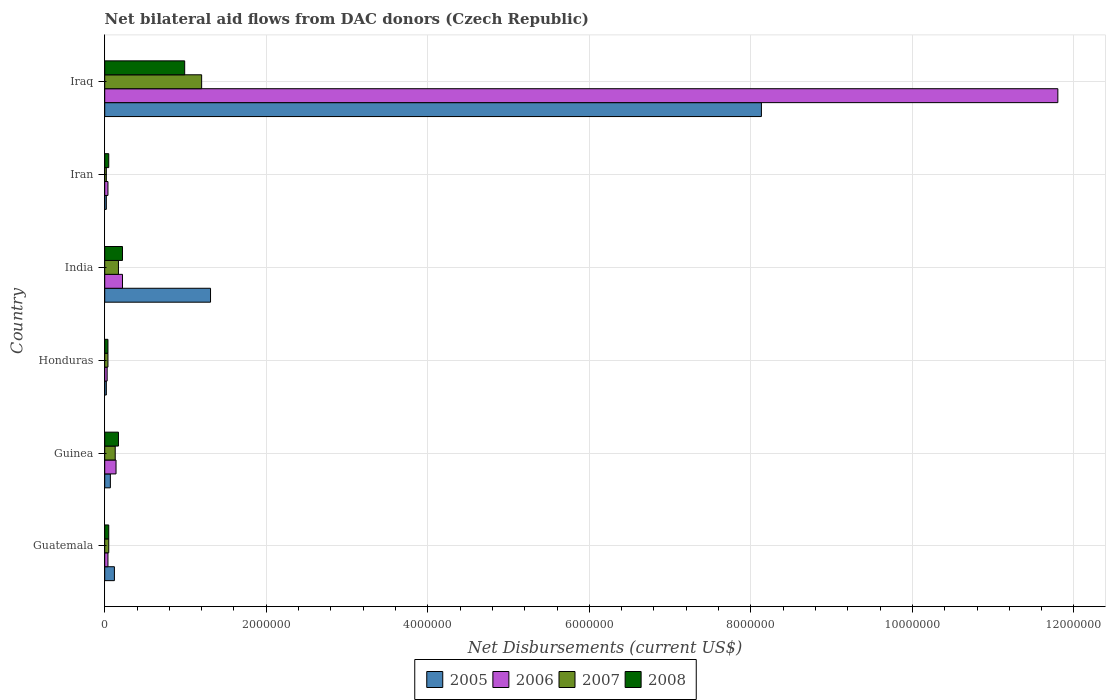How many groups of bars are there?
Provide a succinct answer. 6. Are the number of bars per tick equal to the number of legend labels?
Your answer should be compact. Yes. Are the number of bars on each tick of the Y-axis equal?
Your answer should be compact. Yes. How many bars are there on the 2nd tick from the top?
Provide a succinct answer. 4. What is the label of the 6th group of bars from the top?
Provide a succinct answer. Guatemala. In how many cases, is the number of bars for a given country not equal to the number of legend labels?
Offer a very short reply. 0. Across all countries, what is the maximum net bilateral aid flows in 2007?
Provide a succinct answer. 1.20e+06. Across all countries, what is the minimum net bilateral aid flows in 2007?
Ensure brevity in your answer.  2.00e+04. In which country was the net bilateral aid flows in 2008 maximum?
Make the answer very short. Iraq. In which country was the net bilateral aid flows in 2005 minimum?
Your answer should be very brief. Honduras. What is the total net bilateral aid flows in 2008 in the graph?
Provide a short and direct response. 1.52e+06. What is the difference between the net bilateral aid flows in 2005 in Guinea and that in Iraq?
Offer a terse response. -8.06e+06. What is the difference between the net bilateral aid flows in 2007 in Guinea and the net bilateral aid flows in 2006 in Iran?
Offer a terse response. 9.00e+04. What is the average net bilateral aid flows in 2007 per country?
Make the answer very short. 2.68e+05. What is the ratio of the net bilateral aid flows in 2008 in India to that in Iraq?
Your response must be concise. 0.22. Is the difference between the net bilateral aid flows in 2005 in Guinea and Iraq greater than the difference between the net bilateral aid flows in 2006 in Guinea and Iraq?
Your response must be concise. Yes. What is the difference between the highest and the second highest net bilateral aid flows in 2007?
Offer a very short reply. 1.03e+06. What is the difference between the highest and the lowest net bilateral aid flows in 2006?
Offer a very short reply. 1.18e+07. In how many countries, is the net bilateral aid flows in 2006 greater than the average net bilateral aid flows in 2006 taken over all countries?
Keep it short and to the point. 1. Is the sum of the net bilateral aid flows in 2005 in Guatemala and Guinea greater than the maximum net bilateral aid flows in 2006 across all countries?
Give a very brief answer. No. Is it the case that in every country, the sum of the net bilateral aid flows in 2007 and net bilateral aid flows in 2008 is greater than the sum of net bilateral aid flows in 2005 and net bilateral aid flows in 2006?
Offer a terse response. No. What does the 1st bar from the top in Guinea represents?
Offer a very short reply. 2008. What does the 4th bar from the bottom in Iran represents?
Your answer should be very brief. 2008. How many bars are there?
Your response must be concise. 24. How many countries are there in the graph?
Give a very brief answer. 6. What is the difference between two consecutive major ticks on the X-axis?
Offer a terse response. 2.00e+06. Does the graph contain any zero values?
Ensure brevity in your answer.  No. Where does the legend appear in the graph?
Your response must be concise. Bottom center. What is the title of the graph?
Ensure brevity in your answer.  Net bilateral aid flows from DAC donors (Czech Republic). What is the label or title of the X-axis?
Provide a short and direct response. Net Disbursements (current US$). What is the Net Disbursements (current US$) of 2005 in Guatemala?
Offer a terse response. 1.20e+05. What is the Net Disbursements (current US$) of 2005 in Guinea?
Provide a succinct answer. 7.00e+04. What is the Net Disbursements (current US$) of 2006 in Guinea?
Provide a short and direct response. 1.40e+05. What is the Net Disbursements (current US$) of 2008 in Guinea?
Keep it short and to the point. 1.70e+05. What is the Net Disbursements (current US$) of 2006 in Honduras?
Keep it short and to the point. 3.00e+04. What is the Net Disbursements (current US$) of 2007 in Honduras?
Provide a succinct answer. 4.00e+04. What is the Net Disbursements (current US$) in 2005 in India?
Keep it short and to the point. 1.31e+06. What is the Net Disbursements (current US$) of 2007 in India?
Ensure brevity in your answer.  1.70e+05. What is the Net Disbursements (current US$) in 2008 in India?
Make the answer very short. 2.20e+05. What is the Net Disbursements (current US$) of 2005 in Iran?
Provide a succinct answer. 2.00e+04. What is the Net Disbursements (current US$) in 2006 in Iran?
Keep it short and to the point. 4.00e+04. What is the Net Disbursements (current US$) of 2007 in Iran?
Give a very brief answer. 2.00e+04. What is the Net Disbursements (current US$) of 2008 in Iran?
Give a very brief answer. 5.00e+04. What is the Net Disbursements (current US$) in 2005 in Iraq?
Keep it short and to the point. 8.13e+06. What is the Net Disbursements (current US$) in 2006 in Iraq?
Your answer should be compact. 1.18e+07. What is the Net Disbursements (current US$) of 2007 in Iraq?
Ensure brevity in your answer.  1.20e+06. What is the Net Disbursements (current US$) of 2008 in Iraq?
Provide a succinct answer. 9.90e+05. Across all countries, what is the maximum Net Disbursements (current US$) of 2005?
Offer a terse response. 8.13e+06. Across all countries, what is the maximum Net Disbursements (current US$) of 2006?
Ensure brevity in your answer.  1.18e+07. Across all countries, what is the maximum Net Disbursements (current US$) of 2007?
Provide a short and direct response. 1.20e+06. Across all countries, what is the maximum Net Disbursements (current US$) in 2008?
Offer a very short reply. 9.90e+05. Across all countries, what is the minimum Net Disbursements (current US$) in 2006?
Give a very brief answer. 3.00e+04. Across all countries, what is the minimum Net Disbursements (current US$) in 2007?
Give a very brief answer. 2.00e+04. What is the total Net Disbursements (current US$) in 2005 in the graph?
Provide a short and direct response. 9.67e+06. What is the total Net Disbursements (current US$) of 2006 in the graph?
Your response must be concise. 1.23e+07. What is the total Net Disbursements (current US$) in 2007 in the graph?
Ensure brevity in your answer.  1.61e+06. What is the total Net Disbursements (current US$) in 2008 in the graph?
Your answer should be compact. 1.52e+06. What is the difference between the Net Disbursements (current US$) of 2005 in Guatemala and that in Guinea?
Make the answer very short. 5.00e+04. What is the difference between the Net Disbursements (current US$) in 2006 in Guatemala and that in Guinea?
Make the answer very short. -1.00e+05. What is the difference between the Net Disbursements (current US$) in 2007 in Guatemala and that in Guinea?
Offer a terse response. -8.00e+04. What is the difference between the Net Disbursements (current US$) of 2005 in Guatemala and that in Honduras?
Make the answer very short. 1.00e+05. What is the difference between the Net Disbursements (current US$) in 2006 in Guatemala and that in Honduras?
Ensure brevity in your answer.  10000. What is the difference between the Net Disbursements (current US$) in 2007 in Guatemala and that in Honduras?
Offer a very short reply. 10000. What is the difference between the Net Disbursements (current US$) in 2005 in Guatemala and that in India?
Offer a very short reply. -1.19e+06. What is the difference between the Net Disbursements (current US$) in 2006 in Guatemala and that in India?
Offer a very short reply. -1.80e+05. What is the difference between the Net Disbursements (current US$) of 2005 in Guatemala and that in Iran?
Your answer should be compact. 1.00e+05. What is the difference between the Net Disbursements (current US$) in 2006 in Guatemala and that in Iran?
Your response must be concise. 0. What is the difference between the Net Disbursements (current US$) in 2005 in Guatemala and that in Iraq?
Ensure brevity in your answer.  -8.01e+06. What is the difference between the Net Disbursements (current US$) of 2006 in Guatemala and that in Iraq?
Provide a succinct answer. -1.18e+07. What is the difference between the Net Disbursements (current US$) of 2007 in Guatemala and that in Iraq?
Provide a short and direct response. -1.15e+06. What is the difference between the Net Disbursements (current US$) in 2008 in Guatemala and that in Iraq?
Provide a succinct answer. -9.40e+05. What is the difference between the Net Disbursements (current US$) in 2005 in Guinea and that in Honduras?
Keep it short and to the point. 5.00e+04. What is the difference between the Net Disbursements (current US$) of 2005 in Guinea and that in India?
Offer a terse response. -1.24e+06. What is the difference between the Net Disbursements (current US$) of 2007 in Guinea and that in India?
Keep it short and to the point. -4.00e+04. What is the difference between the Net Disbursements (current US$) of 2005 in Guinea and that in Iran?
Make the answer very short. 5.00e+04. What is the difference between the Net Disbursements (current US$) of 2006 in Guinea and that in Iran?
Your response must be concise. 1.00e+05. What is the difference between the Net Disbursements (current US$) in 2008 in Guinea and that in Iran?
Keep it short and to the point. 1.20e+05. What is the difference between the Net Disbursements (current US$) in 2005 in Guinea and that in Iraq?
Your response must be concise. -8.06e+06. What is the difference between the Net Disbursements (current US$) of 2006 in Guinea and that in Iraq?
Give a very brief answer. -1.17e+07. What is the difference between the Net Disbursements (current US$) of 2007 in Guinea and that in Iraq?
Give a very brief answer. -1.07e+06. What is the difference between the Net Disbursements (current US$) in 2008 in Guinea and that in Iraq?
Keep it short and to the point. -8.20e+05. What is the difference between the Net Disbursements (current US$) in 2005 in Honduras and that in India?
Provide a short and direct response. -1.29e+06. What is the difference between the Net Disbursements (current US$) in 2007 in Honduras and that in India?
Your answer should be compact. -1.30e+05. What is the difference between the Net Disbursements (current US$) in 2008 in Honduras and that in India?
Provide a short and direct response. -1.80e+05. What is the difference between the Net Disbursements (current US$) in 2006 in Honduras and that in Iran?
Give a very brief answer. -10000. What is the difference between the Net Disbursements (current US$) in 2008 in Honduras and that in Iran?
Your answer should be compact. -10000. What is the difference between the Net Disbursements (current US$) of 2005 in Honduras and that in Iraq?
Provide a succinct answer. -8.11e+06. What is the difference between the Net Disbursements (current US$) of 2006 in Honduras and that in Iraq?
Offer a very short reply. -1.18e+07. What is the difference between the Net Disbursements (current US$) in 2007 in Honduras and that in Iraq?
Keep it short and to the point. -1.16e+06. What is the difference between the Net Disbursements (current US$) in 2008 in Honduras and that in Iraq?
Offer a terse response. -9.50e+05. What is the difference between the Net Disbursements (current US$) of 2005 in India and that in Iran?
Your answer should be very brief. 1.29e+06. What is the difference between the Net Disbursements (current US$) in 2006 in India and that in Iran?
Your answer should be compact. 1.80e+05. What is the difference between the Net Disbursements (current US$) of 2005 in India and that in Iraq?
Your answer should be compact. -6.82e+06. What is the difference between the Net Disbursements (current US$) of 2006 in India and that in Iraq?
Offer a terse response. -1.16e+07. What is the difference between the Net Disbursements (current US$) in 2007 in India and that in Iraq?
Keep it short and to the point. -1.03e+06. What is the difference between the Net Disbursements (current US$) of 2008 in India and that in Iraq?
Ensure brevity in your answer.  -7.70e+05. What is the difference between the Net Disbursements (current US$) in 2005 in Iran and that in Iraq?
Offer a terse response. -8.11e+06. What is the difference between the Net Disbursements (current US$) in 2006 in Iran and that in Iraq?
Offer a very short reply. -1.18e+07. What is the difference between the Net Disbursements (current US$) of 2007 in Iran and that in Iraq?
Your response must be concise. -1.18e+06. What is the difference between the Net Disbursements (current US$) of 2008 in Iran and that in Iraq?
Offer a very short reply. -9.40e+05. What is the difference between the Net Disbursements (current US$) of 2005 in Guatemala and the Net Disbursements (current US$) of 2006 in Guinea?
Make the answer very short. -2.00e+04. What is the difference between the Net Disbursements (current US$) in 2005 in Guatemala and the Net Disbursements (current US$) in 2007 in Guinea?
Make the answer very short. -10000. What is the difference between the Net Disbursements (current US$) of 2005 in Guatemala and the Net Disbursements (current US$) of 2008 in Guinea?
Ensure brevity in your answer.  -5.00e+04. What is the difference between the Net Disbursements (current US$) of 2006 in Guatemala and the Net Disbursements (current US$) of 2007 in Guinea?
Offer a terse response. -9.00e+04. What is the difference between the Net Disbursements (current US$) in 2007 in Guatemala and the Net Disbursements (current US$) in 2008 in Guinea?
Give a very brief answer. -1.20e+05. What is the difference between the Net Disbursements (current US$) of 2005 in Guatemala and the Net Disbursements (current US$) of 2006 in Honduras?
Provide a succinct answer. 9.00e+04. What is the difference between the Net Disbursements (current US$) in 2005 in Guatemala and the Net Disbursements (current US$) in 2008 in Honduras?
Provide a succinct answer. 8.00e+04. What is the difference between the Net Disbursements (current US$) of 2007 in Guatemala and the Net Disbursements (current US$) of 2008 in Honduras?
Your response must be concise. 10000. What is the difference between the Net Disbursements (current US$) of 2005 in Guatemala and the Net Disbursements (current US$) of 2007 in India?
Offer a very short reply. -5.00e+04. What is the difference between the Net Disbursements (current US$) of 2006 in Guatemala and the Net Disbursements (current US$) of 2008 in India?
Provide a succinct answer. -1.80e+05. What is the difference between the Net Disbursements (current US$) in 2007 in Guatemala and the Net Disbursements (current US$) in 2008 in India?
Offer a terse response. -1.70e+05. What is the difference between the Net Disbursements (current US$) in 2005 in Guatemala and the Net Disbursements (current US$) in 2006 in Iran?
Offer a very short reply. 8.00e+04. What is the difference between the Net Disbursements (current US$) of 2006 in Guatemala and the Net Disbursements (current US$) of 2007 in Iran?
Keep it short and to the point. 2.00e+04. What is the difference between the Net Disbursements (current US$) in 2006 in Guatemala and the Net Disbursements (current US$) in 2008 in Iran?
Provide a succinct answer. -10000. What is the difference between the Net Disbursements (current US$) in 2005 in Guatemala and the Net Disbursements (current US$) in 2006 in Iraq?
Your answer should be compact. -1.17e+07. What is the difference between the Net Disbursements (current US$) in 2005 in Guatemala and the Net Disbursements (current US$) in 2007 in Iraq?
Give a very brief answer. -1.08e+06. What is the difference between the Net Disbursements (current US$) in 2005 in Guatemala and the Net Disbursements (current US$) in 2008 in Iraq?
Offer a terse response. -8.70e+05. What is the difference between the Net Disbursements (current US$) in 2006 in Guatemala and the Net Disbursements (current US$) in 2007 in Iraq?
Keep it short and to the point. -1.16e+06. What is the difference between the Net Disbursements (current US$) in 2006 in Guatemala and the Net Disbursements (current US$) in 2008 in Iraq?
Offer a very short reply. -9.50e+05. What is the difference between the Net Disbursements (current US$) of 2007 in Guatemala and the Net Disbursements (current US$) of 2008 in Iraq?
Offer a very short reply. -9.40e+05. What is the difference between the Net Disbursements (current US$) in 2005 in Guinea and the Net Disbursements (current US$) in 2006 in Honduras?
Make the answer very short. 4.00e+04. What is the difference between the Net Disbursements (current US$) of 2005 in Guinea and the Net Disbursements (current US$) of 2007 in Honduras?
Keep it short and to the point. 3.00e+04. What is the difference between the Net Disbursements (current US$) of 2005 in Guinea and the Net Disbursements (current US$) of 2008 in Honduras?
Keep it short and to the point. 3.00e+04. What is the difference between the Net Disbursements (current US$) in 2006 in Guinea and the Net Disbursements (current US$) in 2007 in Honduras?
Offer a terse response. 1.00e+05. What is the difference between the Net Disbursements (current US$) of 2006 in Guinea and the Net Disbursements (current US$) of 2008 in Honduras?
Give a very brief answer. 1.00e+05. What is the difference between the Net Disbursements (current US$) in 2005 in Guinea and the Net Disbursements (current US$) in 2006 in India?
Offer a very short reply. -1.50e+05. What is the difference between the Net Disbursements (current US$) in 2007 in Guinea and the Net Disbursements (current US$) in 2008 in India?
Give a very brief answer. -9.00e+04. What is the difference between the Net Disbursements (current US$) in 2005 in Guinea and the Net Disbursements (current US$) in 2007 in Iran?
Offer a very short reply. 5.00e+04. What is the difference between the Net Disbursements (current US$) in 2005 in Guinea and the Net Disbursements (current US$) in 2008 in Iran?
Make the answer very short. 2.00e+04. What is the difference between the Net Disbursements (current US$) in 2007 in Guinea and the Net Disbursements (current US$) in 2008 in Iran?
Your answer should be compact. 8.00e+04. What is the difference between the Net Disbursements (current US$) in 2005 in Guinea and the Net Disbursements (current US$) in 2006 in Iraq?
Make the answer very short. -1.17e+07. What is the difference between the Net Disbursements (current US$) in 2005 in Guinea and the Net Disbursements (current US$) in 2007 in Iraq?
Your answer should be compact. -1.13e+06. What is the difference between the Net Disbursements (current US$) of 2005 in Guinea and the Net Disbursements (current US$) of 2008 in Iraq?
Offer a very short reply. -9.20e+05. What is the difference between the Net Disbursements (current US$) of 2006 in Guinea and the Net Disbursements (current US$) of 2007 in Iraq?
Offer a very short reply. -1.06e+06. What is the difference between the Net Disbursements (current US$) in 2006 in Guinea and the Net Disbursements (current US$) in 2008 in Iraq?
Your response must be concise. -8.50e+05. What is the difference between the Net Disbursements (current US$) in 2007 in Guinea and the Net Disbursements (current US$) in 2008 in Iraq?
Provide a succinct answer. -8.60e+05. What is the difference between the Net Disbursements (current US$) of 2006 in Honduras and the Net Disbursements (current US$) of 2007 in India?
Offer a terse response. -1.40e+05. What is the difference between the Net Disbursements (current US$) in 2006 in Honduras and the Net Disbursements (current US$) in 2008 in India?
Keep it short and to the point. -1.90e+05. What is the difference between the Net Disbursements (current US$) in 2007 in Honduras and the Net Disbursements (current US$) in 2008 in India?
Your answer should be compact. -1.80e+05. What is the difference between the Net Disbursements (current US$) of 2005 in Honduras and the Net Disbursements (current US$) of 2006 in Iran?
Offer a terse response. -2.00e+04. What is the difference between the Net Disbursements (current US$) of 2005 in Honduras and the Net Disbursements (current US$) of 2007 in Iran?
Your response must be concise. 0. What is the difference between the Net Disbursements (current US$) of 2005 in Honduras and the Net Disbursements (current US$) of 2008 in Iran?
Your answer should be very brief. -3.00e+04. What is the difference between the Net Disbursements (current US$) of 2006 in Honduras and the Net Disbursements (current US$) of 2007 in Iran?
Ensure brevity in your answer.  10000. What is the difference between the Net Disbursements (current US$) of 2007 in Honduras and the Net Disbursements (current US$) of 2008 in Iran?
Offer a very short reply. -10000. What is the difference between the Net Disbursements (current US$) of 2005 in Honduras and the Net Disbursements (current US$) of 2006 in Iraq?
Provide a succinct answer. -1.18e+07. What is the difference between the Net Disbursements (current US$) in 2005 in Honduras and the Net Disbursements (current US$) in 2007 in Iraq?
Your answer should be very brief. -1.18e+06. What is the difference between the Net Disbursements (current US$) of 2005 in Honduras and the Net Disbursements (current US$) of 2008 in Iraq?
Provide a succinct answer. -9.70e+05. What is the difference between the Net Disbursements (current US$) of 2006 in Honduras and the Net Disbursements (current US$) of 2007 in Iraq?
Ensure brevity in your answer.  -1.17e+06. What is the difference between the Net Disbursements (current US$) in 2006 in Honduras and the Net Disbursements (current US$) in 2008 in Iraq?
Keep it short and to the point. -9.60e+05. What is the difference between the Net Disbursements (current US$) of 2007 in Honduras and the Net Disbursements (current US$) of 2008 in Iraq?
Ensure brevity in your answer.  -9.50e+05. What is the difference between the Net Disbursements (current US$) in 2005 in India and the Net Disbursements (current US$) in 2006 in Iran?
Your answer should be compact. 1.27e+06. What is the difference between the Net Disbursements (current US$) in 2005 in India and the Net Disbursements (current US$) in 2007 in Iran?
Provide a succinct answer. 1.29e+06. What is the difference between the Net Disbursements (current US$) of 2005 in India and the Net Disbursements (current US$) of 2008 in Iran?
Make the answer very short. 1.26e+06. What is the difference between the Net Disbursements (current US$) in 2006 in India and the Net Disbursements (current US$) in 2008 in Iran?
Your response must be concise. 1.70e+05. What is the difference between the Net Disbursements (current US$) in 2005 in India and the Net Disbursements (current US$) in 2006 in Iraq?
Offer a terse response. -1.05e+07. What is the difference between the Net Disbursements (current US$) in 2006 in India and the Net Disbursements (current US$) in 2007 in Iraq?
Keep it short and to the point. -9.80e+05. What is the difference between the Net Disbursements (current US$) of 2006 in India and the Net Disbursements (current US$) of 2008 in Iraq?
Give a very brief answer. -7.70e+05. What is the difference between the Net Disbursements (current US$) in 2007 in India and the Net Disbursements (current US$) in 2008 in Iraq?
Offer a very short reply. -8.20e+05. What is the difference between the Net Disbursements (current US$) of 2005 in Iran and the Net Disbursements (current US$) of 2006 in Iraq?
Provide a succinct answer. -1.18e+07. What is the difference between the Net Disbursements (current US$) in 2005 in Iran and the Net Disbursements (current US$) in 2007 in Iraq?
Keep it short and to the point. -1.18e+06. What is the difference between the Net Disbursements (current US$) in 2005 in Iran and the Net Disbursements (current US$) in 2008 in Iraq?
Your response must be concise. -9.70e+05. What is the difference between the Net Disbursements (current US$) of 2006 in Iran and the Net Disbursements (current US$) of 2007 in Iraq?
Ensure brevity in your answer.  -1.16e+06. What is the difference between the Net Disbursements (current US$) of 2006 in Iran and the Net Disbursements (current US$) of 2008 in Iraq?
Offer a very short reply. -9.50e+05. What is the difference between the Net Disbursements (current US$) of 2007 in Iran and the Net Disbursements (current US$) of 2008 in Iraq?
Offer a terse response. -9.70e+05. What is the average Net Disbursements (current US$) in 2005 per country?
Offer a terse response. 1.61e+06. What is the average Net Disbursements (current US$) of 2006 per country?
Offer a terse response. 2.04e+06. What is the average Net Disbursements (current US$) of 2007 per country?
Provide a short and direct response. 2.68e+05. What is the average Net Disbursements (current US$) of 2008 per country?
Make the answer very short. 2.53e+05. What is the difference between the Net Disbursements (current US$) in 2005 and Net Disbursements (current US$) in 2006 in Guatemala?
Give a very brief answer. 8.00e+04. What is the difference between the Net Disbursements (current US$) in 2005 and Net Disbursements (current US$) in 2007 in Guatemala?
Offer a terse response. 7.00e+04. What is the difference between the Net Disbursements (current US$) in 2005 and Net Disbursements (current US$) in 2008 in Guatemala?
Provide a short and direct response. 7.00e+04. What is the difference between the Net Disbursements (current US$) in 2006 and Net Disbursements (current US$) in 2008 in Guatemala?
Offer a very short reply. -10000. What is the difference between the Net Disbursements (current US$) in 2005 and Net Disbursements (current US$) in 2007 in Guinea?
Provide a short and direct response. -6.00e+04. What is the difference between the Net Disbursements (current US$) in 2006 and Net Disbursements (current US$) in 2007 in Guinea?
Your response must be concise. 10000. What is the difference between the Net Disbursements (current US$) in 2005 and Net Disbursements (current US$) in 2006 in Honduras?
Give a very brief answer. -10000. What is the difference between the Net Disbursements (current US$) in 2006 and Net Disbursements (current US$) in 2007 in Honduras?
Offer a terse response. -10000. What is the difference between the Net Disbursements (current US$) in 2005 and Net Disbursements (current US$) in 2006 in India?
Your response must be concise. 1.09e+06. What is the difference between the Net Disbursements (current US$) of 2005 and Net Disbursements (current US$) of 2007 in India?
Ensure brevity in your answer.  1.14e+06. What is the difference between the Net Disbursements (current US$) in 2005 and Net Disbursements (current US$) in 2008 in India?
Offer a terse response. 1.09e+06. What is the difference between the Net Disbursements (current US$) in 2006 and Net Disbursements (current US$) in 2007 in India?
Your answer should be compact. 5.00e+04. What is the difference between the Net Disbursements (current US$) in 2007 and Net Disbursements (current US$) in 2008 in India?
Offer a terse response. -5.00e+04. What is the difference between the Net Disbursements (current US$) in 2005 and Net Disbursements (current US$) in 2006 in Iran?
Offer a very short reply. -2.00e+04. What is the difference between the Net Disbursements (current US$) in 2005 and Net Disbursements (current US$) in 2007 in Iran?
Offer a very short reply. 0. What is the difference between the Net Disbursements (current US$) of 2005 and Net Disbursements (current US$) of 2008 in Iran?
Ensure brevity in your answer.  -3.00e+04. What is the difference between the Net Disbursements (current US$) in 2006 and Net Disbursements (current US$) in 2008 in Iran?
Keep it short and to the point. -10000. What is the difference between the Net Disbursements (current US$) in 2005 and Net Disbursements (current US$) in 2006 in Iraq?
Ensure brevity in your answer.  -3.67e+06. What is the difference between the Net Disbursements (current US$) in 2005 and Net Disbursements (current US$) in 2007 in Iraq?
Your answer should be very brief. 6.93e+06. What is the difference between the Net Disbursements (current US$) in 2005 and Net Disbursements (current US$) in 2008 in Iraq?
Your answer should be very brief. 7.14e+06. What is the difference between the Net Disbursements (current US$) in 2006 and Net Disbursements (current US$) in 2007 in Iraq?
Make the answer very short. 1.06e+07. What is the difference between the Net Disbursements (current US$) of 2006 and Net Disbursements (current US$) of 2008 in Iraq?
Your answer should be very brief. 1.08e+07. What is the ratio of the Net Disbursements (current US$) in 2005 in Guatemala to that in Guinea?
Offer a terse response. 1.71. What is the ratio of the Net Disbursements (current US$) of 2006 in Guatemala to that in Guinea?
Make the answer very short. 0.29. What is the ratio of the Net Disbursements (current US$) of 2007 in Guatemala to that in Guinea?
Ensure brevity in your answer.  0.38. What is the ratio of the Net Disbursements (current US$) of 2008 in Guatemala to that in Guinea?
Give a very brief answer. 0.29. What is the ratio of the Net Disbursements (current US$) of 2005 in Guatemala to that in Honduras?
Provide a succinct answer. 6. What is the ratio of the Net Disbursements (current US$) in 2005 in Guatemala to that in India?
Give a very brief answer. 0.09. What is the ratio of the Net Disbursements (current US$) in 2006 in Guatemala to that in India?
Provide a succinct answer. 0.18. What is the ratio of the Net Disbursements (current US$) in 2007 in Guatemala to that in India?
Provide a short and direct response. 0.29. What is the ratio of the Net Disbursements (current US$) of 2008 in Guatemala to that in India?
Offer a very short reply. 0.23. What is the ratio of the Net Disbursements (current US$) of 2007 in Guatemala to that in Iran?
Make the answer very short. 2.5. What is the ratio of the Net Disbursements (current US$) of 2008 in Guatemala to that in Iran?
Your answer should be very brief. 1. What is the ratio of the Net Disbursements (current US$) of 2005 in Guatemala to that in Iraq?
Ensure brevity in your answer.  0.01. What is the ratio of the Net Disbursements (current US$) in 2006 in Guatemala to that in Iraq?
Provide a succinct answer. 0. What is the ratio of the Net Disbursements (current US$) of 2007 in Guatemala to that in Iraq?
Provide a short and direct response. 0.04. What is the ratio of the Net Disbursements (current US$) in 2008 in Guatemala to that in Iraq?
Give a very brief answer. 0.05. What is the ratio of the Net Disbursements (current US$) of 2006 in Guinea to that in Honduras?
Offer a terse response. 4.67. What is the ratio of the Net Disbursements (current US$) in 2008 in Guinea to that in Honduras?
Ensure brevity in your answer.  4.25. What is the ratio of the Net Disbursements (current US$) in 2005 in Guinea to that in India?
Ensure brevity in your answer.  0.05. What is the ratio of the Net Disbursements (current US$) in 2006 in Guinea to that in India?
Offer a terse response. 0.64. What is the ratio of the Net Disbursements (current US$) of 2007 in Guinea to that in India?
Offer a very short reply. 0.76. What is the ratio of the Net Disbursements (current US$) in 2008 in Guinea to that in India?
Your answer should be very brief. 0.77. What is the ratio of the Net Disbursements (current US$) of 2005 in Guinea to that in Iran?
Give a very brief answer. 3.5. What is the ratio of the Net Disbursements (current US$) of 2007 in Guinea to that in Iran?
Your answer should be compact. 6.5. What is the ratio of the Net Disbursements (current US$) of 2005 in Guinea to that in Iraq?
Your answer should be very brief. 0.01. What is the ratio of the Net Disbursements (current US$) of 2006 in Guinea to that in Iraq?
Your answer should be very brief. 0.01. What is the ratio of the Net Disbursements (current US$) in 2007 in Guinea to that in Iraq?
Your answer should be compact. 0.11. What is the ratio of the Net Disbursements (current US$) in 2008 in Guinea to that in Iraq?
Make the answer very short. 0.17. What is the ratio of the Net Disbursements (current US$) of 2005 in Honduras to that in India?
Your answer should be compact. 0.02. What is the ratio of the Net Disbursements (current US$) in 2006 in Honduras to that in India?
Your answer should be compact. 0.14. What is the ratio of the Net Disbursements (current US$) of 2007 in Honduras to that in India?
Provide a short and direct response. 0.24. What is the ratio of the Net Disbursements (current US$) in 2008 in Honduras to that in India?
Keep it short and to the point. 0.18. What is the ratio of the Net Disbursements (current US$) of 2005 in Honduras to that in Iran?
Offer a very short reply. 1. What is the ratio of the Net Disbursements (current US$) in 2008 in Honduras to that in Iran?
Provide a succinct answer. 0.8. What is the ratio of the Net Disbursements (current US$) in 2005 in Honduras to that in Iraq?
Provide a short and direct response. 0. What is the ratio of the Net Disbursements (current US$) in 2006 in Honduras to that in Iraq?
Your response must be concise. 0. What is the ratio of the Net Disbursements (current US$) of 2007 in Honduras to that in Iraq?
Make the answer very short. 0.03. What is the ratio of the Net Disbursements (current US$) of 2008 in Honduras to that in Iraq?
Provide a succinct answer. 0.04. What is the ratio of the Net Disbursements (current US$) in 2005 in India to that in Iran?
Make the answer very short. 65.5. What is the ratio of the Net Disbursements (current US$) of 2005 in India to that in Iraq?
Your answer should be compact. 0.16. What is the ratio of the Net Disbursements (current US$) in 2006 in India to that in Iraq?
Your answer should be very brief. 0.02. What is the ratio of the Net Disbursements (current US$) in 2007 in India to that in Iraq?
Provide a short and direct response. 0.14. What is the ratio of the Net Disbursements (current US$) of 2008 in India to that in Iraq?
Your response must be concise. 0.22. What is the ratio of the Net Disbursements (current US$) of 2005 in Iran to that in Iraq?
Offer a terse response. 0. What is the ratio of the Net Disbursements (current US$) in 2006 in Iran to that in Iraq?
Give a very brief answer. 0. What is the ratio of the Net Disbursements (current US$) in 2007 in Iran to that in Iraq?
Ensure brevity in your answer.  0.02. What is the ratio of the Net Disbursements (current US$) of 2008 in Iran to that in Iraq?
Your answer should be very brief. 0.05. What is the difference between the highest and the second highest Net Disbursements (current US$) in 2005?
Your answer should be compact. 6.82e+06. What is the difference between the highest and the second highest Net Disbursements (current US$) of 2006?
Offer a very short reply. 1.16e+07. What is the difference between the highest and the second highest Net Disbursements (current US$) in 2007?
Your answer should be compact. 1.03e+06. What is the difference between the highest and the second highest Net Disbursements (current US$) of 2008?
Provide a short and direct response. 7.70e+05. What is the difference between the highest and the lowest Net Disbursements (current US$) of 2005?
Provide a short and direct response. 8.11e+06. What is the difference between the highest and the lowest Net Disbursements (current US$) of 2006?
Your answer should be compact. 1.18e+07. What is the difference between the highest and the lowest Net Disbursements (current US$) of 2007?
Provide a succinct answer. 1.18e+06. What is the difference between the highest and the lowest Net Disbursements (current US$) of 2008?
Your answer should be very brief. 9.50e+05. 